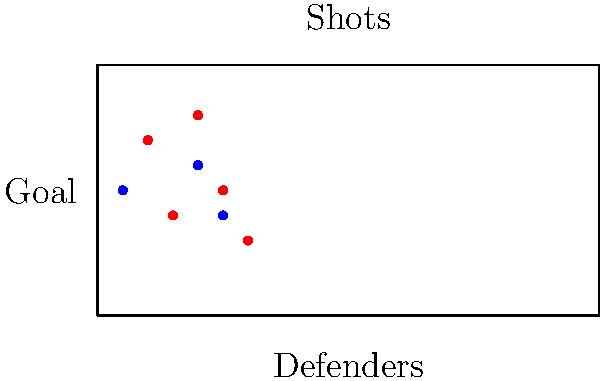Given the shot chart and defensive player positions shown in the diagram, which machine learning model would be most appropriate for estimating the probability of a goal being scored, similar to analyzing Ovechkin's scoring chances? To estimate the probability of a goal being scored based on shot locations and defensive player positions, we need to consider several factors:

1. The problem involves predicting a binary outcome (goal or no goal), which suggests a classification task.

2. We have multiple input features:
   a. x and y coordinates of the shot
   b. x and y coordinates of defensive players
   c. Potentially derived features like distance to goal, angles, etc.

3. The relationship between these features and the goal probability is likely to be complex and non-linear.

4. We want to output a probability rather than just a binary classification.

Given these considerations, the most appropriate model would be a Logistic Regression or a more complex model like Random Forest or Gradient Boosting Machines.

However, considering the complexity of the problem and the potential for capturing non-linear relationships, a Neural Network would be the most suitable choice. Specifically, a Multi-Layer Perceptron (MLP) with the following characteristics:

1. Input layer: Features including shot coordinates, defender coordinates, and derived features.
2. Hidden layers: Multiple layers to capture complex patterns.
3. Output layer: A single neuron with a sigmoid activation function to output a probability between 0 and 1.

This model can learn intricate patterns in the data, similar to how one would analyze Ovechkin's scoring prowess from various positions on the ice while considering defensive coverage.
Answer: Neural Network (Multi-Layer Perceptron) 